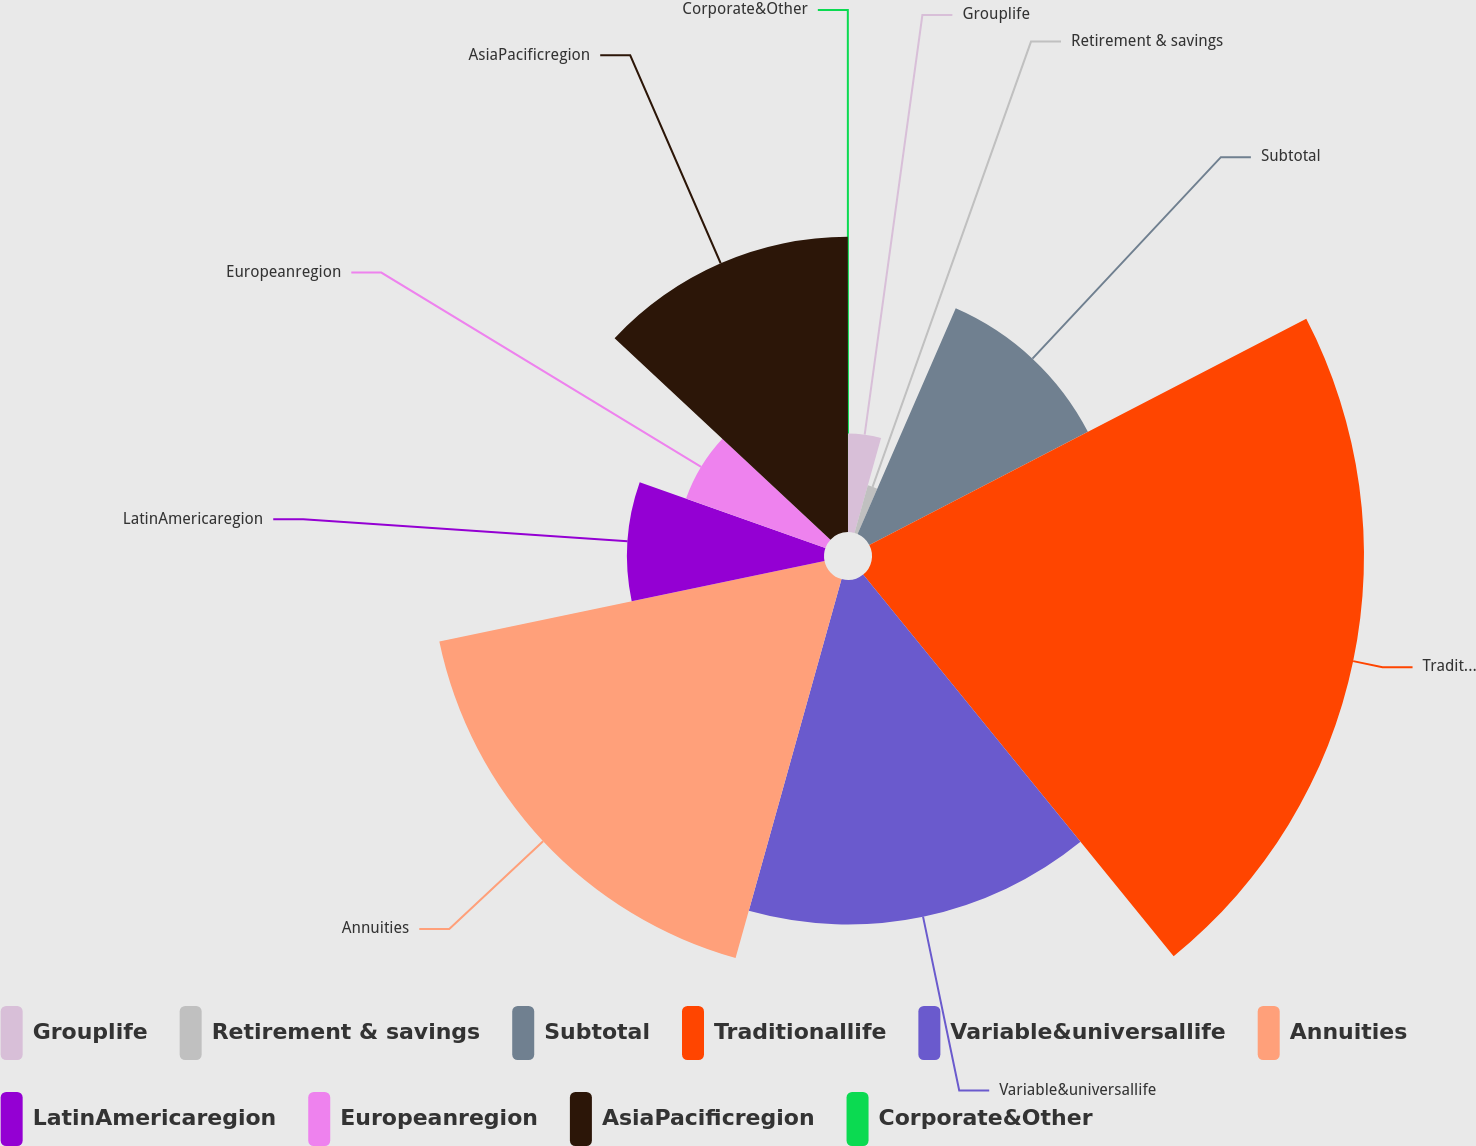Convert chart to OTSL. <chart><loc_0><loc_0><loc_500><loc_500><pie_chart><fcel>Grouplife<fcel>Retirement & savings<fcel>Subtotal<fcel>Traditionallife<fcel>Variable&universallife<fcel>Annuities<fcel>LatinAmericaregion<fcel>Europeanregion<fcel>AsiaPacificregion<fcel>Corporate&Other<nl><fcel>4.35%<fcel>2.18%<fcel>10.87%<fcel>21.73%<fcel>15.21%<fcel>17.38%<fcel>8.7%<fcel>6.53%<fcel>13.04%<fcel>0.01%<nl></chart> 